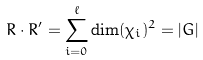<formula> <loc_0><loc_0><loc_500><loc_500>R \cdot R ^ { \prime } = \sum _ { i = 0 } ^ { \ell } \dim ( \chi _ { i } ) ^ { 2 } = | G |</formula> 